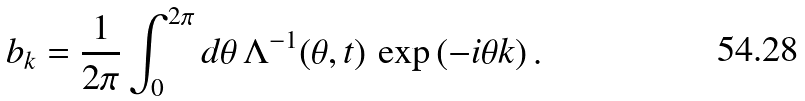<formula> <loc_0><loc_0><loc_500><loc_500>b _ { k } = \frac { 1 } { 2 \pi } \int _ { 0 } ^ { 2 \pi } d \theta \, \Lambda ^ { - 1 } ( \theta , t ) \, \exp \left ( - i \theta k \right ) .</formula> 